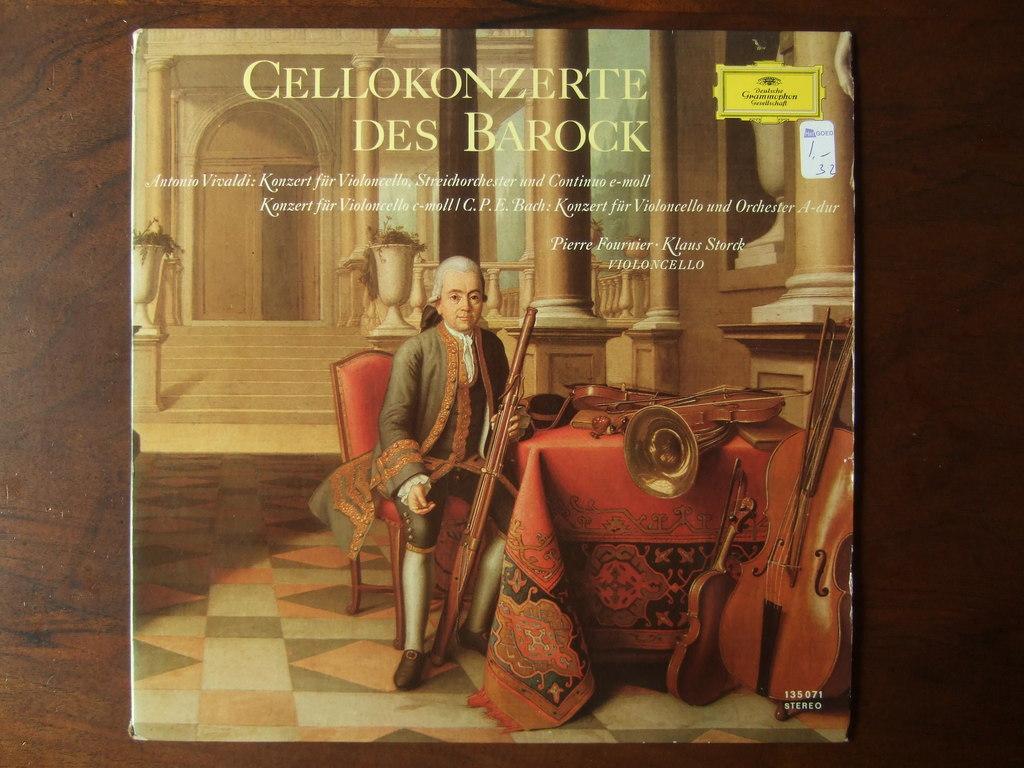What is subject of the book?
Give a very brief answer. Unanswerable. What is the name of this book?
Offer a terse response. Cellokonzerte des barock. 